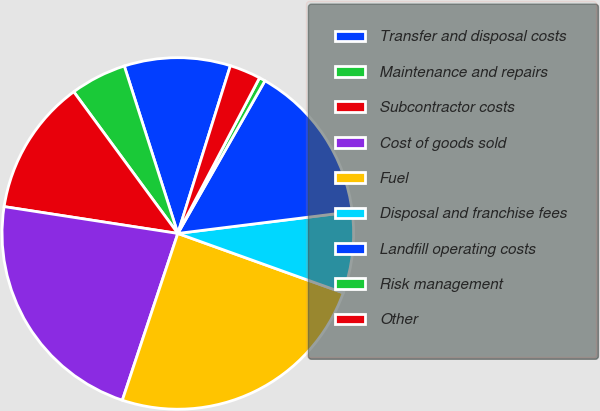Convert chart. <chart><loc_0><loc_0><loc_500><loc_500><pie_chart><fcel>Transfer and disposal costs<fcel>Maintenance and repairs<fcel>Subcontractor costs<fcel>Cost of goods sold<fcel>Fuel<fcel>Disposal and franchise fees<fcel>Landfill operating costs<fcel>Risk management<fcel>Other<nl><fcel>9.76%<fcel>5.16%<fcel>12.48%<fcel>22.33%<fcel>24.63%<fcel>7.46%<fcel>14.78%<fcel>0.56%<fcel>2.86%<nl></chart> 